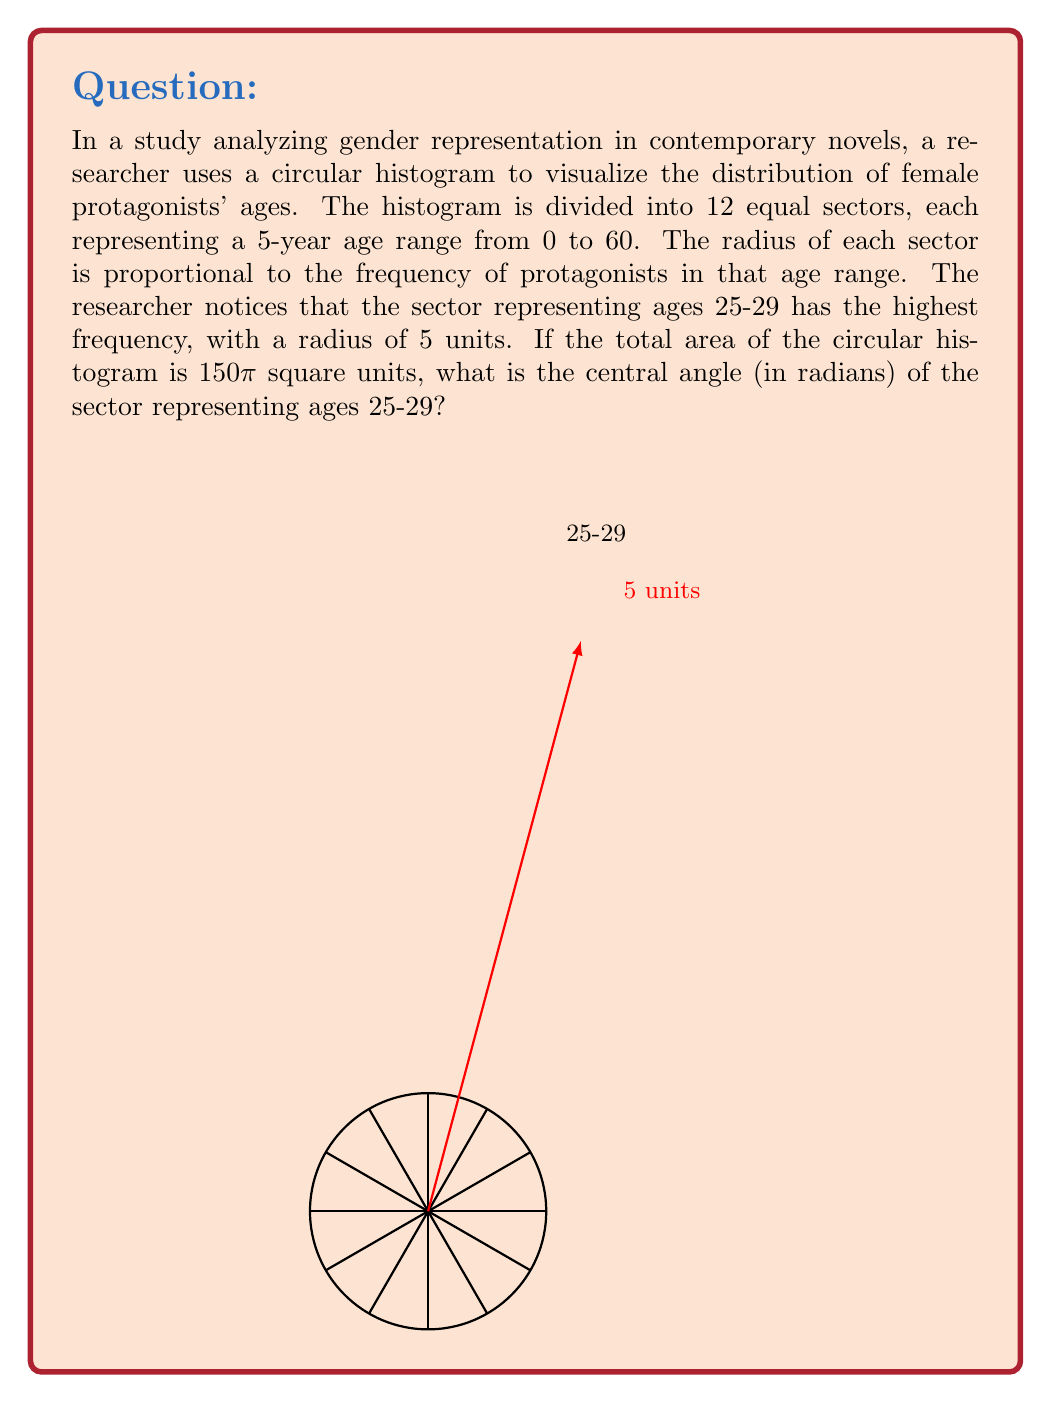Show me your answer to this math problem. Let's approach this step-by-step:

1) The total area of a circle is given by $A = \pi r^2$. We're told the total area is 150π square units, so:

   $150\pi = \pi r^2$
   $r^2 = 150$
   $r = \sqrt{150} \approx 12.25$ units

2) The area of a sector is given by $A_{sector} = \frac{1}{2}r^2\theta$, where θ is the central angle in radians.

3) We know the sector for ages 25-29 has a radius of 5 units. Let's call its central angle $\theta_x$. Its area is:

   $A_{25-29} = \frac{1}{2} \cdot 5^2 \cdot \theta_x = \frac{25}{2}\theta_x$

4) The total area of the circle can be expressed as the sum of all sector areas. Since there are 12 sectors, and the 25-29 sector has the largest area, we can write:

   $150\pi = \frac{25}{2}\theta_x + 11 \cdot \frac{25}{2}\theta_y$

   where $\theta_y$ is the central angle of each of the other 11 sectors.

5) We also know that the sum of all central angles must be $2\pi$ radians:

   $\theta_x + 11\theta_y = 2\pi$

6) From step 4, we can express $\theta_y$ in terms of $\theta_x$:

   $\theta_y = \frac{2\pi - \theta_x}{11}$

7) Substituting this into the equation from step 4:

   $150\pi = \frac{25}{2}\theta_x + 11 \cdot \frac{25}{2} \cdot \frac{2\pi - \theta_x}{11}$

8) Simplifying:

   $150\pi = \frac{25}{2}\theta_x + \frac{25}{2}(2\pi - \theta_x) = 25\pi - \frac{25}{2}\theta_x$

9) Solving for $\theta_x$:

   $\frac{25}{2}\theta_x = 25\pi - 150\pi = -125\pi$
   $\theta_x = -10\pi$

10) Since the angle must be positive, we take the absolute value:

    $\theta_x = 10\pi$ radians
Answer: $10\pi$ radians 